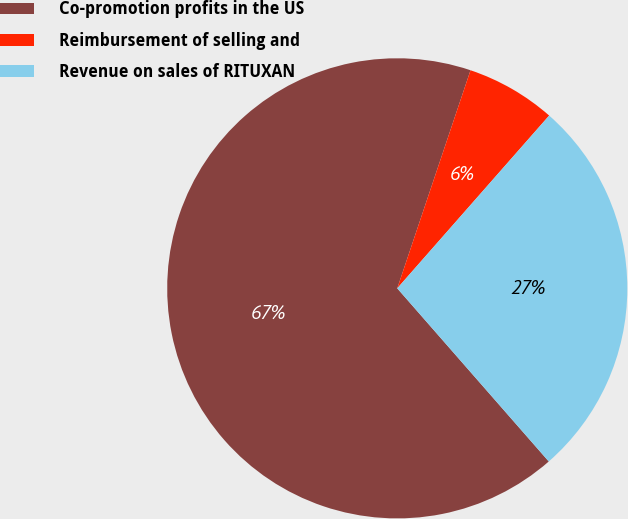Convert chart to OTSL. <chart><loc_0><loc_0><loc_500><loc_500><pie_chart><fcel>Co-promotion profits in the US<fcel>Reimbursement of selling and<fcel>Revenue on sales of RITUXAN<nl><fcel>66.6%<fcel>6.32%<fcel>27.08%<nl></chart> 